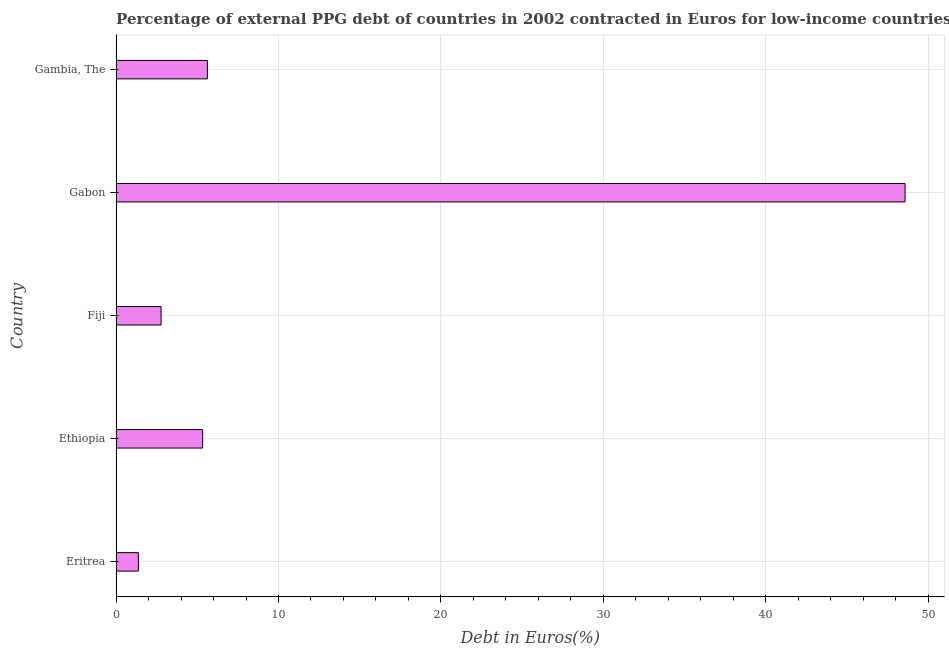Does the graph contain grids?
Your response must be concise. Yes. What is the title of the graph?
Offer a very short reply. Percentage of external PPG debt of countries in 2002 contracted in Euros for low-income countries. What is the label or title of the X-axis?
Your response must be concise. Debt in Euros(%). What is the currency composition of ppg debt in Ethiopia?
Offer a terse response. 5.33. Across all countries, what is the maximum currency composition of ppg debt?
Your response must be concise. 48.59. Across all countries, what is the minimum currency composition of ppg debt?
Your answer should be compact. 1.37. In which country was the currency composition of ppg debt maximum?
Give a very brief answer. Gabon. In which country was the currency composition of ppg debt minimum?
Keep it short and to the point. Eritrea. What is the sum of the currency composition of ppg debt?
Your answer should be very brief. 63.67. What is the difference between the currency composition of ppg debt in Ethiopia and Gabon?
Make the answer very short. -43.26. What is the average currency composition of ppg debt per country?
Your answer should be compact. 12.73. What is the median currency composition of ppg debt?
Your answer should be compact. 5.33. In how many countries, is the currency composition of ppg debt greater than 2 %?
Keep it short and to the point. 4. What is the ratio of the currency composition of ppg debt in Eritrea to that in Gambia, The?
Offer a terse response. 0.24. Is the currency composition of ppg debt in Ethiopia less than that in Gambia, The?
Keep it short and to the point. Yes. What is the difference between the highest and the second highest currency composition of ppg debt?
Ensure brevity in your answer.  42.97. What is the difference between the highest and the lowest currency composition of ppg debt?
Ensure brevity in your answer.  47.21. In how many countries, is the currency composition of ppg debt greater than the average currency composition of ppg debt taken over all countries?
Ensure brevity in your answer.  1. How many bars are there?
Your response must be concise. 5. How many countries are there in the graph?
Provide a succinct answer. 5. What is the difference between two consecutive major ticks on the X-axis?
Your answer should be very brief. 10. What is the Debt in Euros(%) in Eritrea?
Your answer should be compact. 1.37. What is the Debt in Euros(%) of Ethiopia?
Make the answer very short. 5.33. What is the Debt in Euros(%) of Fiji?
Keep it short and to the point. 2.77. What is the Debt in Euros(%) in Gabon?
Provide a succinct answer. 48.59. What is the Debt in Euros(%) in Gambia, The?
Offer a terse response. 5.62. What is the difference between the Debt in Euros(%) in Eritrea and Ethiopia?
Ensure brevity in your answer.  -3.96. What is the difference between the Debt in Euros(%) in Eritrea and Fiji?
Offer a terse response. -1.39. What is the difference between the Debt in Euros(%) in Eritrea and Gabon?
Your response must be concise. -47.21. What is the difference between the Debt in Euros(%) in Eritrea and Gambia, The?
Give a very brief answer. -4.25. What is the difference between the Debt in Euros(%) in Ethiopia and Fiji?
Ensure brevity in your answer.  2.56. What is the difference between the Debt in Euros(%) in Ethiopia and Gabon?
Your answer should be compact. -43.26. What is the difference between the Debt in Euros(%) in Ethiopia and Gambia, The?
Your answer should be compact. -0.29. What is the difference between the Debt in Euros(%) in Fiji and Gabon?
Your response must be concise. -45.82. What is the difference between the Debt in Euros(%) in Fiji and Gambia, The?
Your answer should be very brief. -2.85. What is the difference between the Debt in Euros(%) in Gabon and Gambia, The?
Your response must be concise. 42.97. What is the ratio of the Debt in Euros(%) in Eritrea to that in Ethiopia?
Make the answer very short. 0.26. What is the ratio of the Debt in Euros(%) in Eritrea to that in Fiji?
Ensure brevity in your answer.  0.5. What is the ratio of the Debt in Euros(%) in Eritrea to that in Gabon?
Offer a terse response. 0.03. What is the ratio of the Debt in Euros(%) in Eritrea to that in Gambia, The?
Keep it short and to the point. 0.24. What is the ratio of the Debt in Euros(%) in Ethiopia to that in Fiji?
Give a very brief answer. 1.93. What is the ratio of the Debt in Euros(%) in Ethiopia to that in Gabon?
Your answer should be very brief. 0.11. What is the ratio of the Debt in Euros(%) in Ethiopia to that in Gambia, The?
Give a very brief answer. 0.95. What is the ratio of the Debt in Euros(%) in Fiji to that in Gabon?
Provide a succinct answer. 0.06. What is the ratio of the Debt in Euros(%) in Fiji to that in Gambia, The?
Your response must be concise. 0.49. What is the ratio of the Debt in Euros(%) in Gabon to that in Gambia, The?
Give a very brief answer. 8.64. 